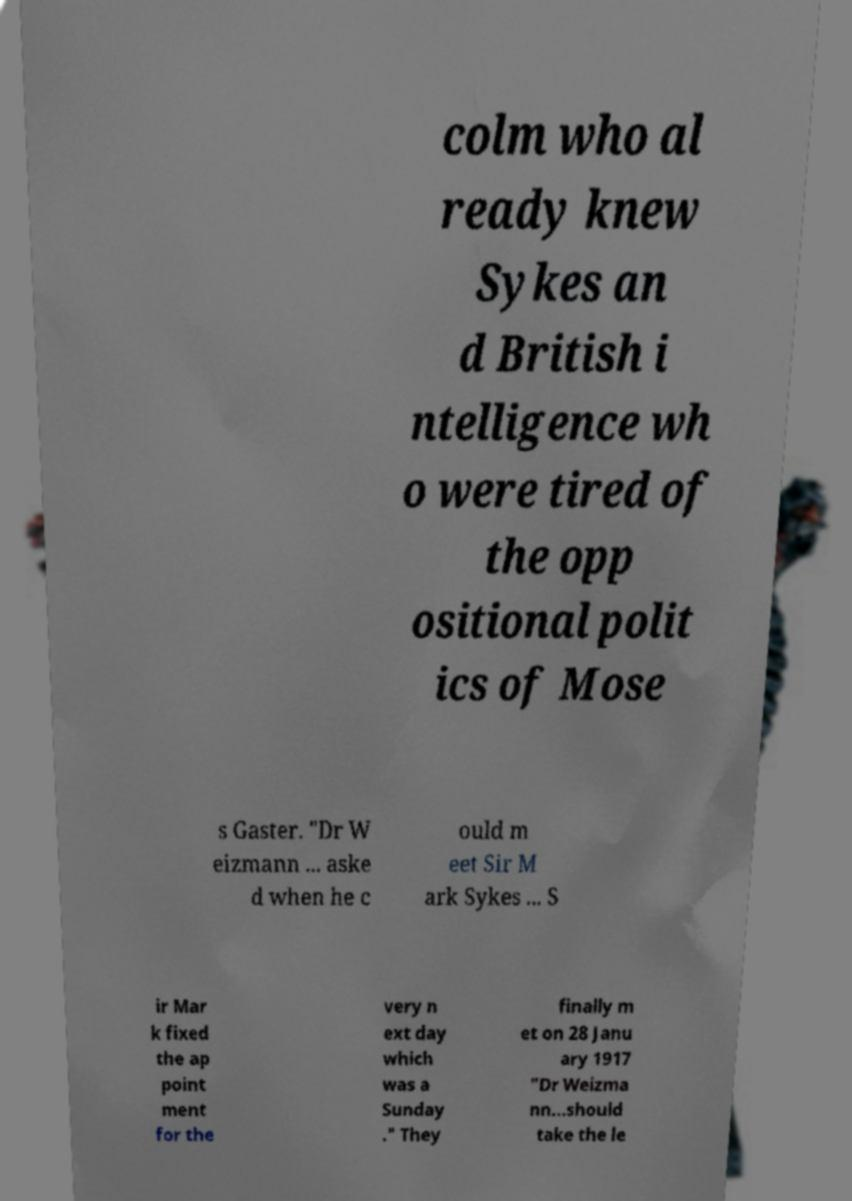Could you assist in decoding the text presented in this image and type it out clearly? colm who al ready knew Sykes an d British i ntelligence wh o were tired of the opp ositional polit ics of Mose s Gaster. "Dr W eizmann ... aske d when he c ould m eet Sir M ark Sykes ... S ir Mar k fixed the ap point ment for the very n ext day which was a Sunday ." They finally m et on 28 Janu ary 1917 "Dr Weizma nn...should take the le 